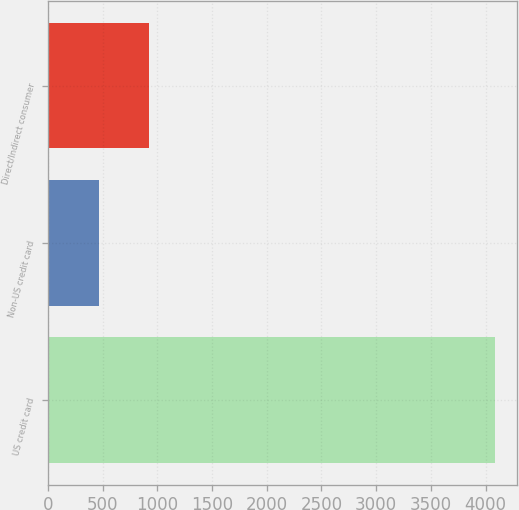Convert chart to OTSL. <chart><loc_0><loc_0><loc_500><loc_500><bar_chart><fcel>US credit card<fcel>Non-US credit card<fcel>Direct/Indirect consumer<nl><fcel>4085<fcel>464<fcel>929<nl></chart> 